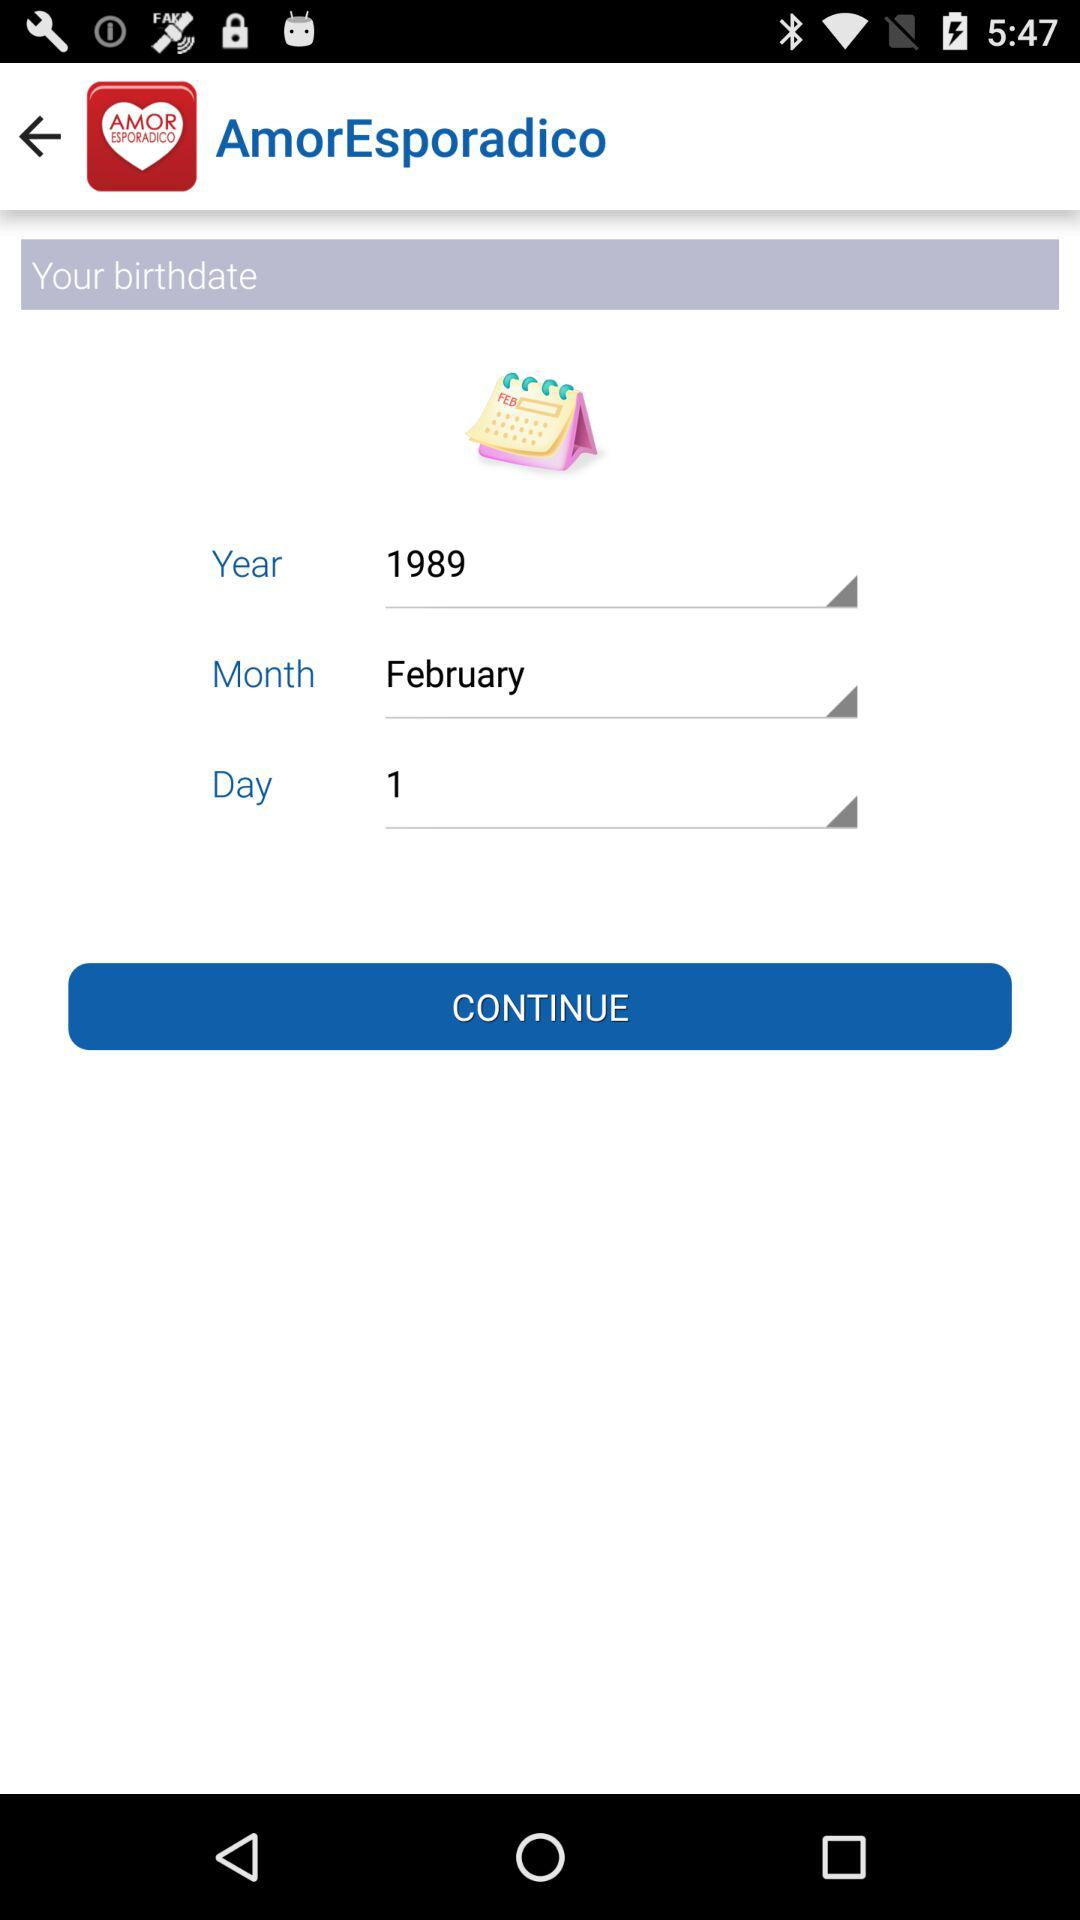Which is the year of birth? The year of birth is 1989. 